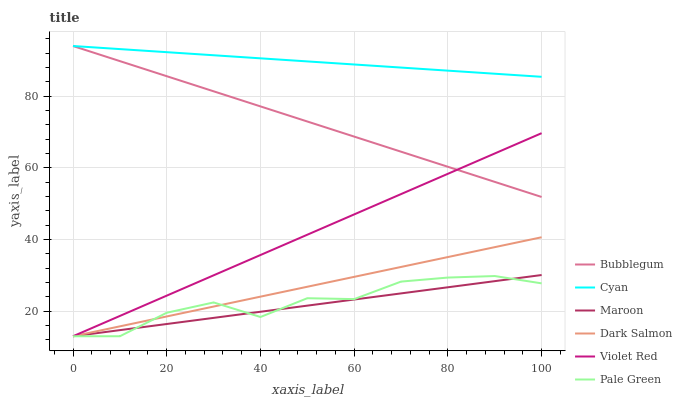Does Maroon have the minimum area under the curve?
Answer yes or no. Yes. Does Cyan have the maximum area under the curve?
Answer yes or no. Yes. Does Dark Salmon have the minimum area under the curve?
Answer yes or no. No. Does Dark Salmon have the maximum area under the curve?
Answer yes or no. No. Is Dark Salmon the smoothest?
Answer yes or no. Yes. Is Pale Green the roughest?
Answer yes or no. Yes. Is Maroon the smoothest?
Answer yes or no. No. Is Maroon the roughest?
Answer yes or no. No. Does Violet Red have the lowest value?
Answer yes or no. Yes. Does Bubblegum have the lowest value?
Answer yes or no. No. Does Cyan have the highest value?
Answer yes or no. Yes. Does Dark Salmon have the highest value?
Answer yes or no. No. Is Violet Red less than Cyan?
Answer yes or no. Yes. Is Bubblegum greater than Dark Salmon?
Answer yes or no. Yes. Does Maroon intersect Dark Salmon?
Answer yes or no. Yes. Is Maroon less than Dark Salmon?
Answer yes or no. No. Is Maroon greater than Dark Salmon?
Answer yes or no. No. Does Violet Red intersect Cyan?
Answer yes or no. No. 